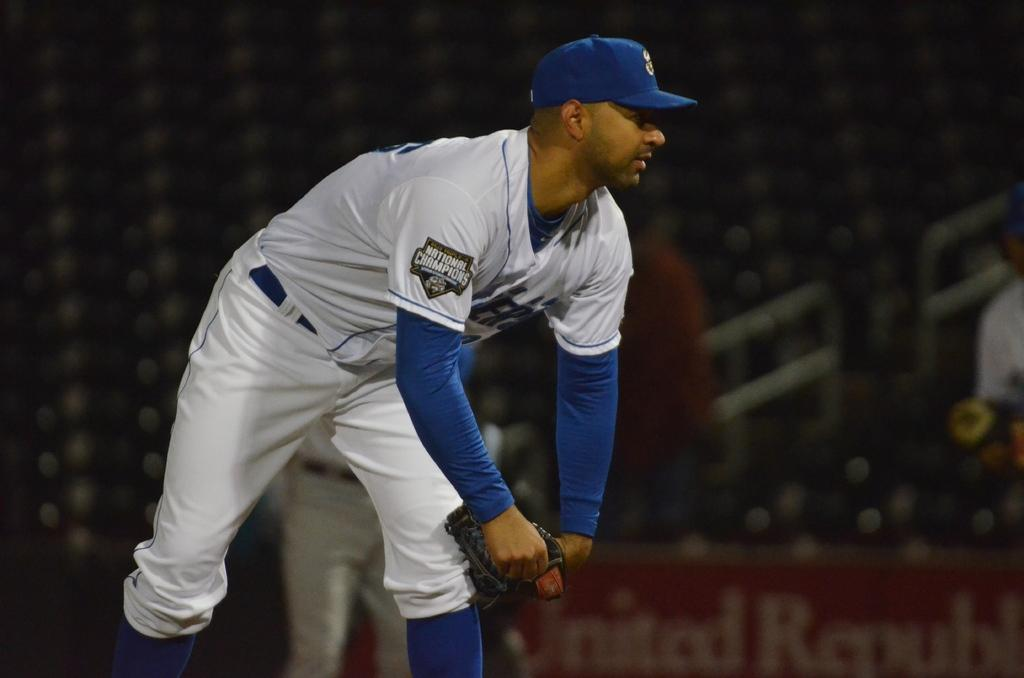<image>
Present a compact description of the photo's key features. Man wearing a baseball jersey that has a tag which says "National Champions". 